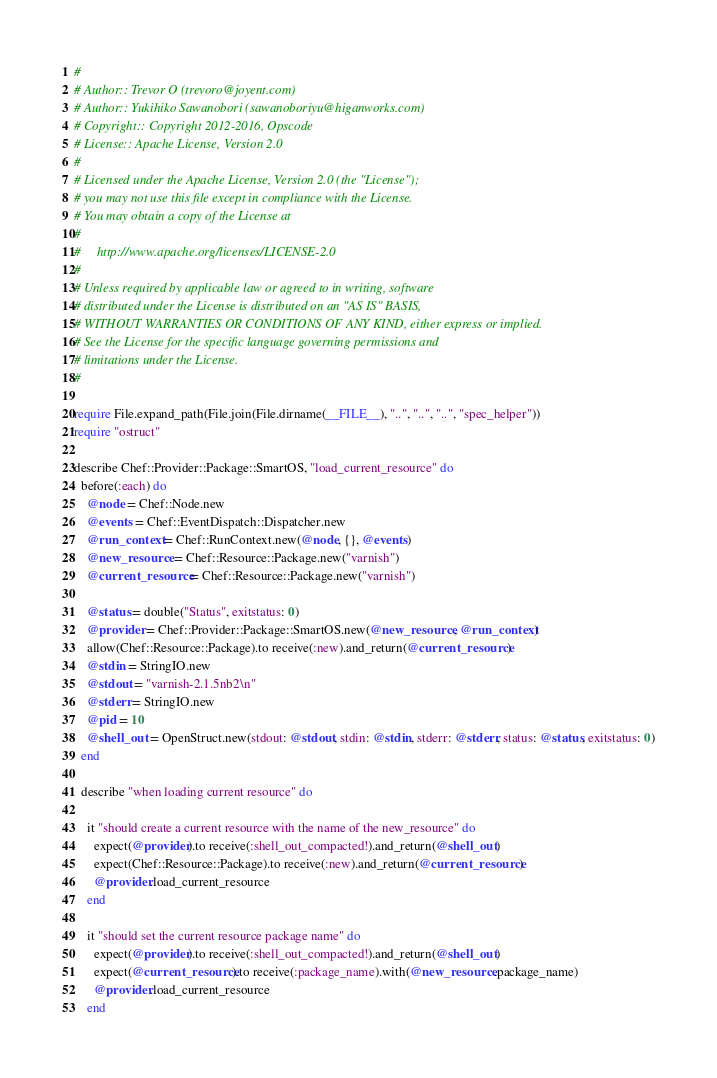Convert code to text. <code><loc_0><loc_0><loc_500><loc_500><_Ruby_>#
# Author:: Trevor O (trevoro@joyent.com)
# Author:: Yukihiko Sawanobori (sawanoboriyu@higanworks.com)
# Copyright:: Copyright 2012-2016, Opscode
# License:: Apache License, Version 2.0
#
# Licensed under the Apache License, Version 2.0 (the "License");
# you may not use this file except in compliance with the License.
# You may obtain a copy of the License at
#
#     http://www.apache.org/licenses/LICENSE-2.0
#
# Unless required by applicable law or agreed to in writing, software
# distributed under the License is distributed on an "AS IS" BASIS,
# WITHOUT WARRANTIES OR CONDITIONS OF ANY KIND, either express or implied.
# See the License for the specific language governing permissions and
# limitations under the License.
#

require File.expand_path(File.join(File.dirname(__FILE__), "..", "..", "..", "spec_helper"))
require "ostruct"

describe Chef::Provider::Package::SmartOS, "load_current_resource" do
  before(:each) do
    @node = Chef::Node.new
    @events = Chef::EventDispatch::Dispatcher.new
    @run_context = Chef::RunContext.new(@node, {}, @events)
    @new_resource = Chef::Resource::Package.new("varnish")
    @current_resource = Chef::Resource::Package.new("varnish")

    @status = double("Status", exitstatus: 0)
    @provider = Chef::Provider::Package::SmartOS.new(@new_resource, @run_context)
    allow(Chef::Resource::Package).to receive(:new).and_return(@current_resource)
    @stdin = StringIO.new
    @stdout = "varnish-2.1.5nb2\n"
    @stderr = StringIO.new
    @pid = 10
    @shell_out = OpenStruct.new(stdout: @stdout, stdin: @stdin, stderr: @stderr, status: @status, exitstatus: 0)
  end

  describe "when loading current resource" do

    it "should create a current resource with the name of the new_resource" do
      expect(@provider).to receive(:shell_out_compacted!).and_return(@shell_out)
      expect(Chef::Resource::Package).to receive(:new).and_return(@current_resource)
      @provider.load_current_resource
    end

    it "should set the current resource package name" do
      expect(@provider).to receive(:shell_out_compacted!).and_return(@shell_out)
      expect(@current_resource).to receive(:package_name).with(@new_resource.package_name)
      @provider.load_current_resource
    end
</code> 